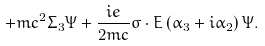<formula> <loc_0><loc_0><loc_500><loc_500>+ m c ^ { 2 } \Sigma _ { 3 } \Psi + \frac { i e } { 2 m c } \sigma \cdot { E } \left ( \alpha _ { 3 } + i \alpha _ { 2 } \right ) \Psi .</formula> 